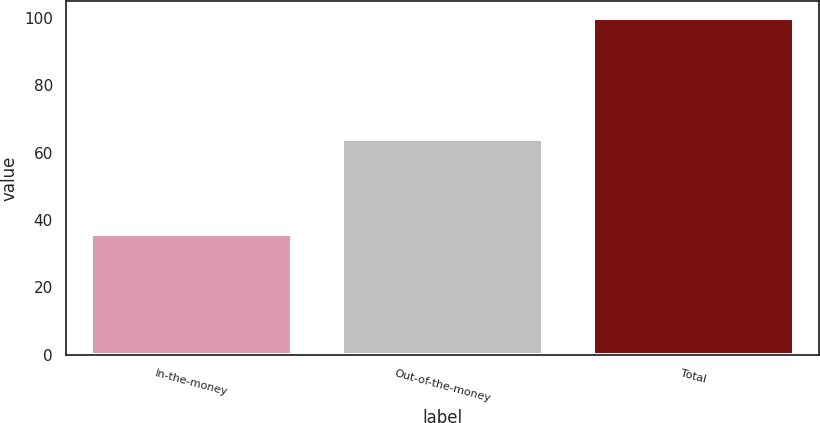Convert chart. <chart><loc_0><loc_0><loc_500><loc_500><bar_chart><fcel>In-the-money<fcel>Out-of-the-money<fcel>Total<nl><fcel>36<fcel>64<fcel>100<nl></chart> 